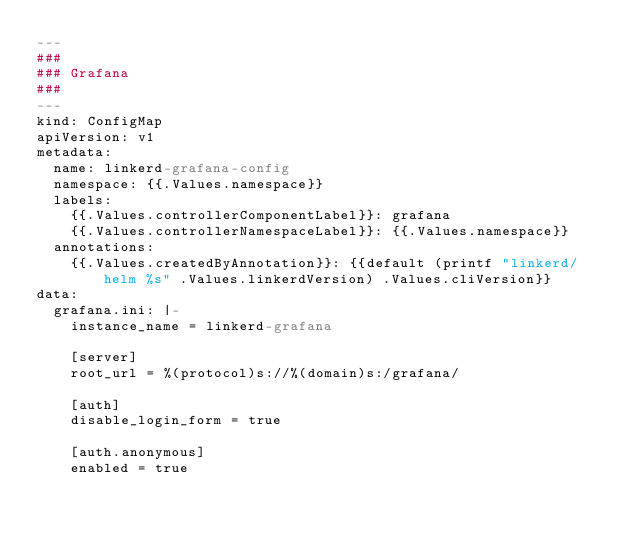Convert code to text. <code><loc_0><loc_0><loc_500><loc_500><_YAML_>---
###
### Grafana
###
---
kind: ConfigMap
apiVersion: v1
metadata:
  name: linkerd-grafana-config
  namespace: {{.Values.namespace}}
  labels:
    {{.Values.controllerComponentLabel}}: grafana
    {{.Values.controllerNamespaceLabel}}: {{.Values.namespace}}
  annotations:
    {{.Values.createdByAnnotation}}: {{default (printf "linkerd/helm %s" .Values.linkerdVersion) .Values.cliVersion}}
data:
  grafana.ini: |-
    instance_name = linkerd-grafana

    [server]
    root_url = %(protocol)s://%(domain)s:/grafana/

    [auth]
    disable_login_form = true

    [auth.anonymous]
    enabled = true</code> 